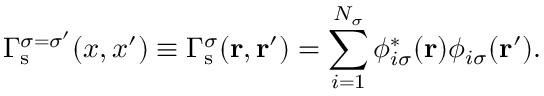Convert formula to latex. <formula><loc_0><loc_0><loc_500><loc_500>\Gamma _ { s } ^ { \sigma = \sigma ^ { \prime } } ( x , x ^ { \prime } ) \equiv \Gamma _ { s } ^ { \sigma } ( r , r ^ { \prime } ) = \sum _ { i = 1 } ^ { N _ { \sigma } } \phi _ { i \sigma } ^ { * } ( r ) \phi _ { i \sigma } ( r ^ { \prime } ) .</formula> 